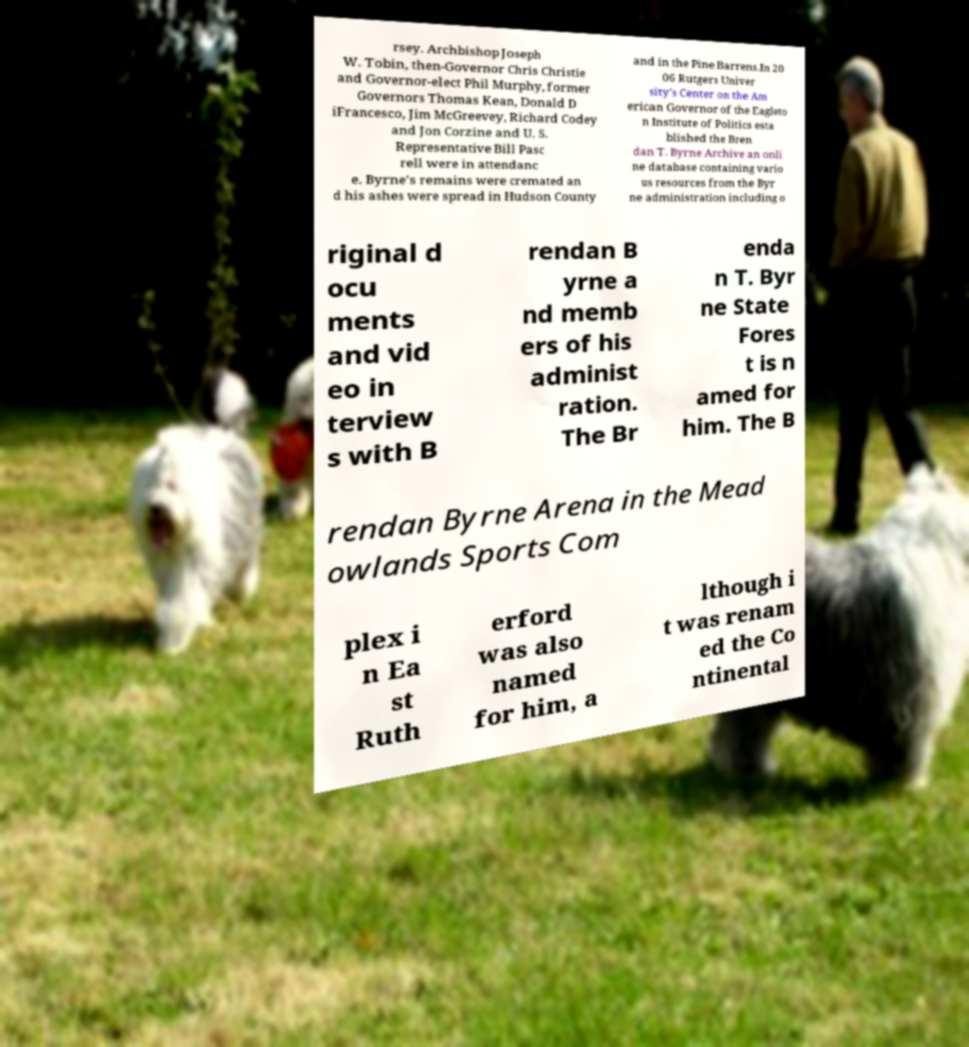I need the written content from this picture converted into text. Can you do that? rsey. Archbishop Joseph W. Tobin, then-Governor Chris Christie and Governor-elect Phil Murphy, former Governors Thomas Kean, Donald D iFrancesco, Jim McGreevey, Richard Codey and Jon Corzine and U. S. Representative Bill Pasc rell were in attendanc e. Byrne's remains were cremated an d his ashes were spread in Hudson County and in the Pine Barrens.In 20 06 Rutgers Univer sity's Center on the Am erican Governor of the Eagleto n Institute of Politics esta blished the Bren dan T. Byrne Archive an onli ne database containing vario us resources from the Byr ne administration including o riginal d ocu ments and vid eo in terview s with B rendan B yrne a nd memb ers of his administ ration. The Br enda n T. Byr ne State Fores t is n amed for him. The B rendan Byrne Arena in the Mead owlands Sports Com plex i n Ea st Ruth erford was also named for him, a lthough i t was renam ed the Co ntinental 